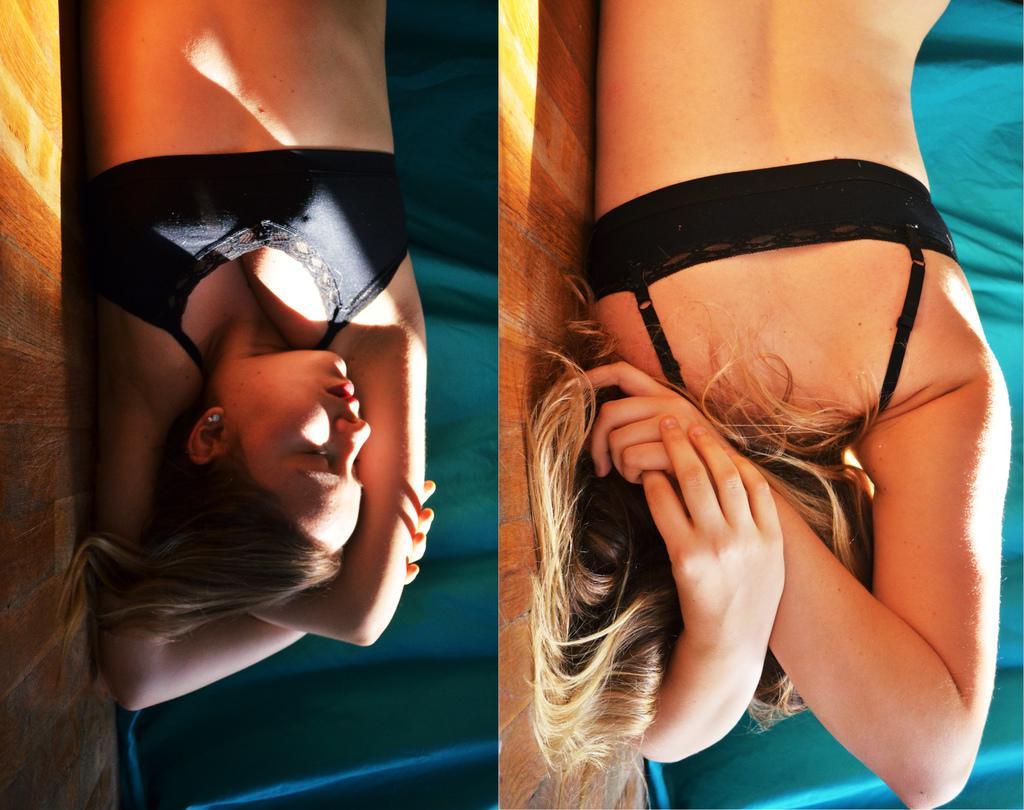Describe this image in one or two sentences. This is a collage picture, I can see a woman laying on the floor, and in the background there is a cloth. 